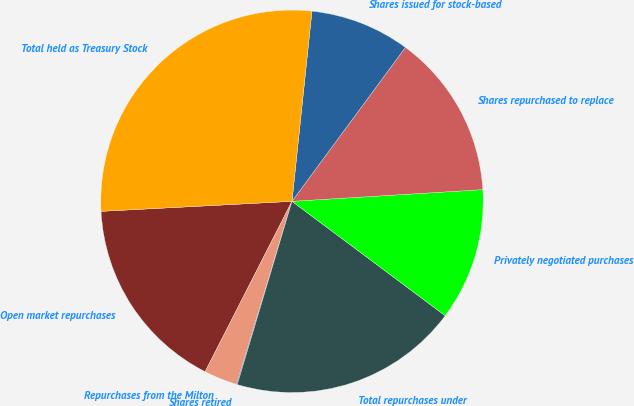<chart> <loc_0><loc_0><loc_500><loc_500><pie_chart><fcel>Open market repurchases<fcel>Repurchases from the Milton<fcel>Shares retired<fcel>Total repurchases under<fcel>Privately negotiated purchases<fcel>Shares repurchased to replace<fcel>Shares issued for stock-based<fcel>Total held as Treasury Stock<nl><fcel>16.66%<fcel>2.82%<fcel>0.07%<fcel>19.41%<fcel>11.18%<fcel>13.92%<fcel>8.44%<fcel>27.5%<nl></chart> 